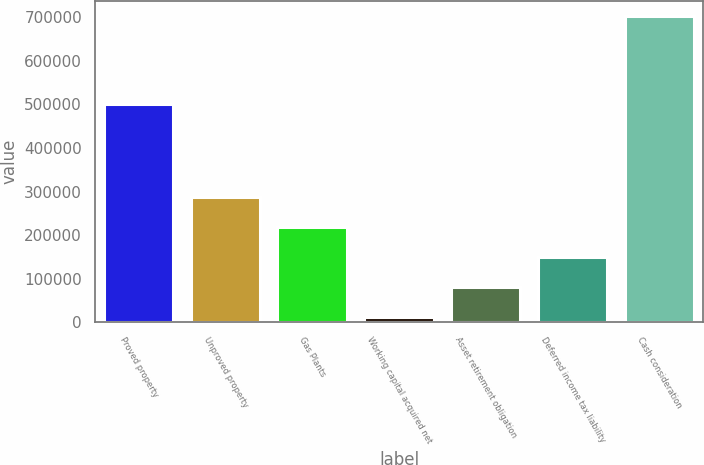Convert chart to OTSL. <chart><loc_0><loc_0><loc_500><loc_500><bar_chart><fcel>Proved property<fcel>Unproved property<fcel>Gas Plants<fcel>Working capital acquired net<fcel>Asset retirement obligation<fcel>Deferred income tax liability<fcel>Cash consideration<nl><fcel>501938<fcel>287805<fcel>218668<fcel>11256<fcel>80393.3<fcel>149531<fcel>702629<nl></chart> 